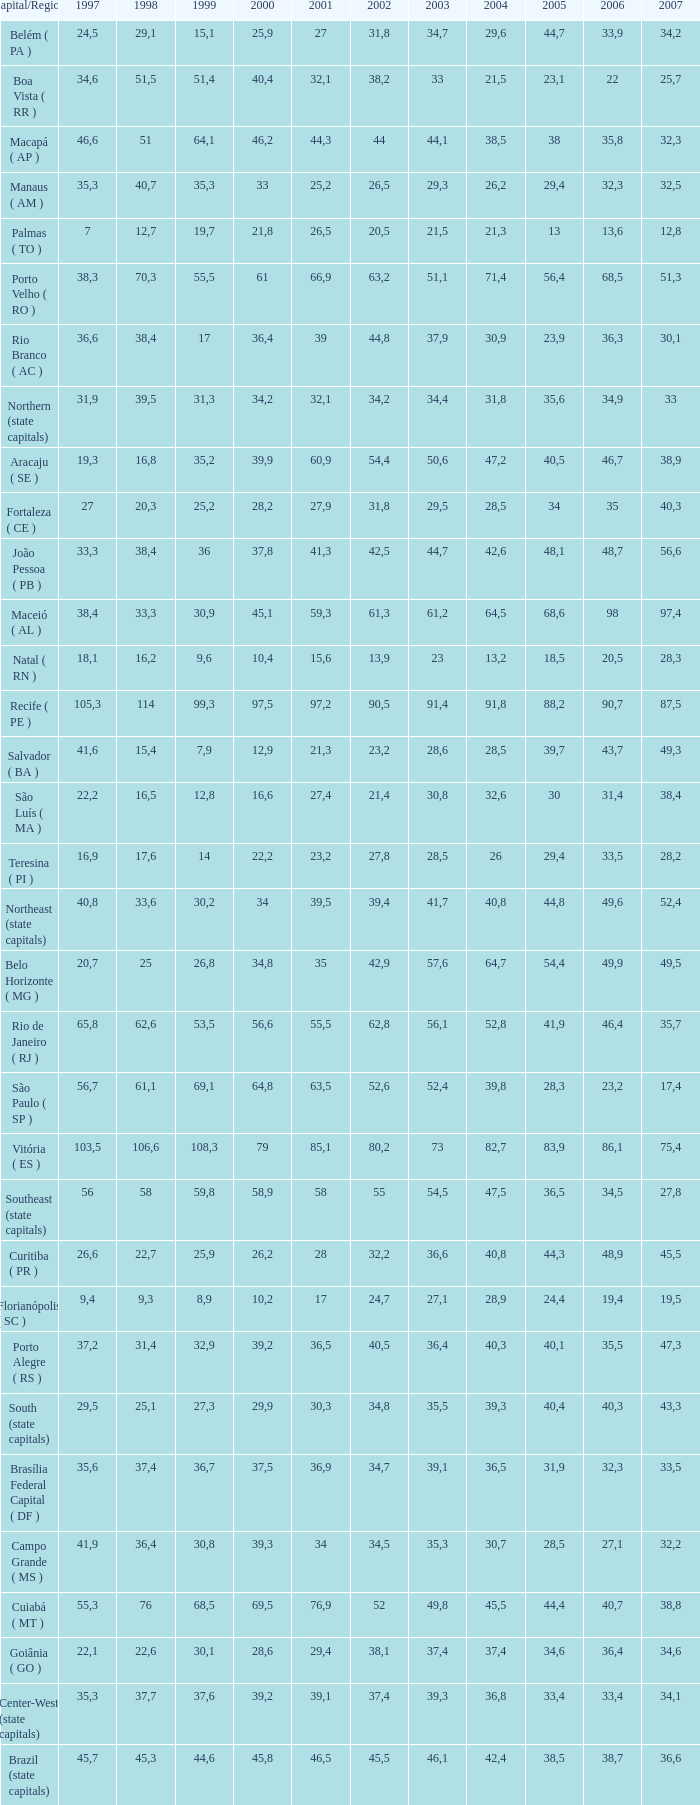Would you mind parsing the complete table? {'header': ['Capital/Region', '1997', '1998', '1999', '2000', '2001', '2002', '2003', '2004', '2005', '2006', '2007'], 'rows': [['Belém ( PA )', '24,5', '29,1', '15,1', '25,9', '27', '31,8', '34,7', '29,6', '44,7', '33,9', '34,2'], ['Boa Vista ( RR )', '34,6', '51,5', '51,4', '40,4', '32,1', '38,2', '33', '21,5', '23,1', '22', '25,7'], ['Macapá ( AP )', '46,6', '51', '64,1', '46,2', '44,3', '44', '44,1', '38,5', '38', '35,8', '32,3'], ['Manaus ( AM )', '35,3', '40,7', '35,3', '33', '25,2', '26,5', '29,3', '26,2', '29,4', '32,3', '32,5'], ['Palmas ( TO )', '7', '12,7', '19,7', '21,8', '26,5', '20,5', '21,5', '21,3', '13', '13,6', '12,8'], ['Porto Velho ( RO )', '38,3', '70,3', '55,5', '61', '66,9', '63,2', '51,1', '71,4', '56,4', '68,5', '51,3'], ['Rio Branco ( AC )', '36,6', '38,4', '17', '36,4', '39', '44,8', '37,9', '30,9', '23,9', '36,3', '30,1'], ['Northern (state capitals)', '31,9', '39,5', '31,3', '34,2', '32,1', '34,2', '34,4', '31,8', '35,6', '34,9', '33'], ['Aracaju ( SE )', '19,3', '16,8', '35,2', '39,9', '60,9', '54,4', '50,6', '47,2', '40,5', '46,7', '38,9'], ['Fortaleza ( CE )', '27', '20,3', '25,2', '28,2', '27,9', '31,8', '29,5', '28,5', '34', '35', '40,3'], ['João Pessoa ( PB )', '33,3', '38,4', '36', '37,8', '41,3', '42,5', '44,7', '42,6', '48,1', '48,7', '56,6'], ['Maceió ( AL )', '38,4', '33,3', '30,9', '45,1', '59,3', '61,3', '61,2', '64,5', '68,6', '98', '97,4'], ['Natal ( RN )', '18,1', '16,2', '9,6', '10,4', '15,6', '13,9', '23', '13,2', '18,5', '20,5', '28,3'], ['Recife ( PE )', '105,3', '114', '99,3', '97,5', '97,2', '90,5', '91,4', '91,8', '88,2', '90,7', '87,5'], ['Salvador ( BA )', '41,6', '15,4', '7,9', '12,9', '21,3', '23,2', '28,6', '28,5', '39,7', '43,7', '49,3'], ['São Luís ( MA )', '22,2', '16,5', '12,8', '16,6', '27,4', '21,4', '30,8', '32,6', '30', '31,4', '38,4'], ['Teresina ( PI )', '16,9', '17,6', '14', '22,2', '23,2', '27,8', '28,5', '26', '29,4', '33,5', '28,2'], ['Northeast (state capitals)', '40,8', '33,6', '30,2', '34', '39,5', '39,4', '41,7', '40,8', '44,8', '49,6', '52,4'], ['Belo Horizonte ( MG )', '20,7', '25', '26,8', '34,8', '35', '42,9', '57,6', '64,7', '54,4', '49,9', '49,5'], ['Rio de Janeiro ( RJ )', '65,8', '62,6', '53,5', '56,6', '55,5', '62,8', '56,1', '52,8', '41,9', '46,4', '35,7'], ['São Paulo ( SP )', '56,7', '61,1', '69,1', '64,8', '63,5', '52,6', '52,4', '39,8', '28,3', '23,2', '17,4'], ['Vitória ( ES )', '103,5', '106,6', '108,3', '79', '85,1', '80,2', '73', '82,7', '83,9', '86,1', '75,4'], ['Southeast (state capitals)', '56', '58', '59,8', '58,9', '58', '55', '54,5', '47,5', '36,5', '34,5', '27,8'], ['Curitiba ( PR )', '26,6', '22,7', '25,9', '26,2', '28', '32,2', '36,6', '40,8', '44,3', '48,9', '45,5'], ['Florianópolis ( SC )', '9,4', '9,3', '8,9', '10,2', '17', '24,7', '27,1', '28,9', '24,4', '19,4', '19,5'], ['Porto Alegre ( RS )', '37,2', '31,4', '32,9', '39,2', '36,5', '40,5', '36,4', '40,3', '40,1', '35,5', '47,3'], ['South (state capitals)', '29,5', '25,1', '27,3', '29,9', '30,3', '34,8', '35,5', '39,3', '40,4', '40,3', '43,3'], ['Brasília Federal Capital ( DF )', '35,6', '37,4', '36,7', '37,5', '36,9', '34,7', '39,1', '36,5', '31,9', '32,3', '33,5'], ['Campo Grande ( MS )', '41,9', '36,4', '30,8', '39,3', '34', '34,5', '35,3', '30,7', '28,5', '27,1', '32,2'], ['Cuiabá ( MT )', '55,3', '76', '68,5', '69,5', '76,9', '52', '49,8', '45,5', '44,4', '40,7', '38,8'], ['Goiânia ( GO )', '22,1', '22,6', '30,1', '28,6', '29,4', '38,1', '37,4', '37,4', '34,6', '36,4', '34,6'], ['Center-West (state capitals)', '35,3', '37,7', '37,6', '39,2', '39,1', '37,4', '39,3', '36,8', '33,4', '33,4', '34,1'], ['Brazil (state capitals)', '45,7', '45,3', '44,6', '45,8', '46,5', '45,5', '46,1', '42,4', '38,5', '38,7', '36,6']]} What is the average 2000 that has a 1997 greater than 34,6, a 2006 greater than 38,7, and a 2998 less than 76? 41.92. 